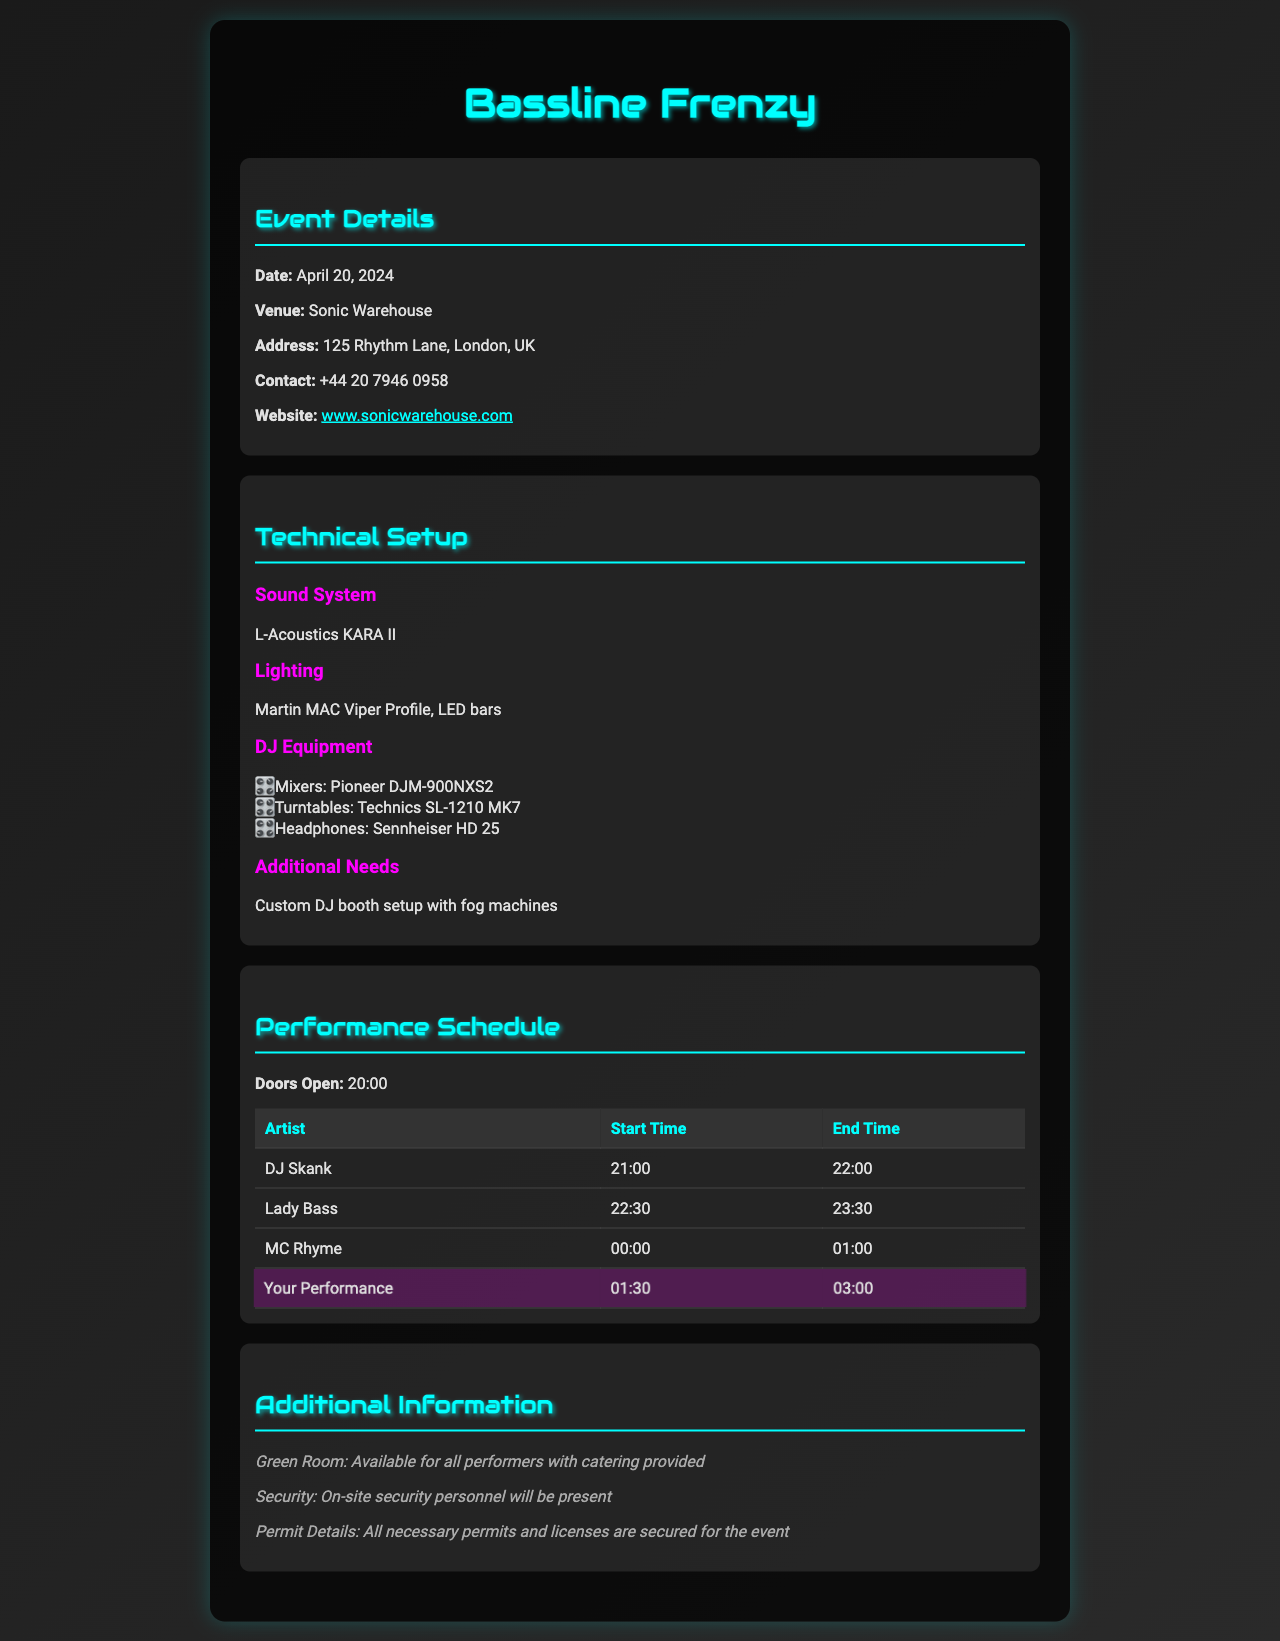What is the date of the event? The date of the event is prominently displayed in the document as April 20, 2024.
Answer: April 20, 2024 What is the venue of the event? The venue is mentioned in the event details section, which states Sonic Warehouse.
Answer: Sonic Warehouse What is the address of the venue? The address can be found in the event details section as 125 Rhythm Lane, London, UK.
Answer: 125 Rhythm Lane, London, UK What is the sound system used? The technical setup specifies that the sound system is L-Acoustics KARA II.
Answer: L-Acoustics KARA II What time does your performance start? The performance schedule clearly indicates that your performance starts at 01:30.
Answer: 01:30 What equipment is used for DJing? The list under DJ Equipment in the technical setup includes mixers, turntables, and headphones.
Answer: Pioneer DJM-900NXS2, Technics SL-1210 MK7, Sennheiser HD 25 Is catering provided for performers? The additional information section notes that the green room includes catering for all performers.
Answer: Yes What is the contact number for the venue? The contact number is listed in the event details as +44 20 7946 0958.
Answer: +44 20 7946 0958 How long is MC Rhyme's performance? The performance schedule shows that MC Rhyme performs for one hour, from 00:00 to 01:00.
Answer: One hour 